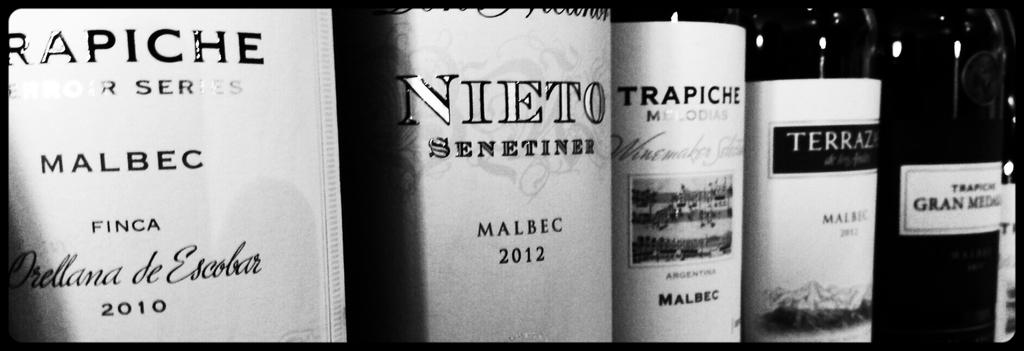Provide a one-sentence caption for the provided image. Bottles of alcohol with labels that say MALBEC on it. 